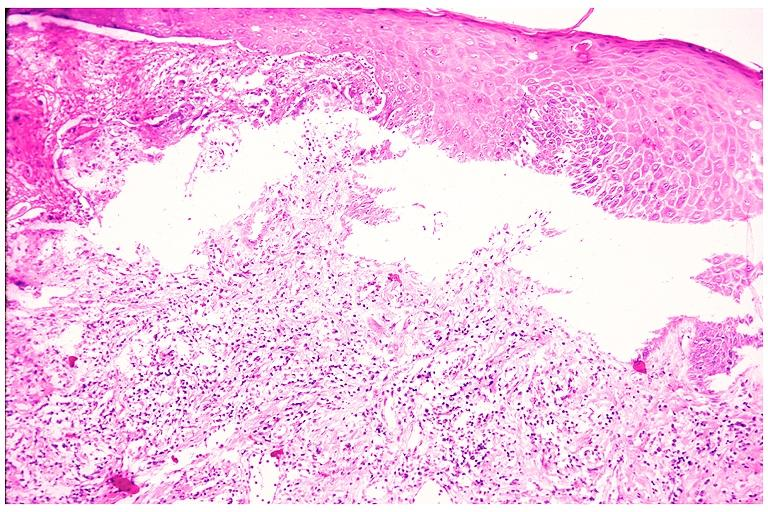does this image show cicatricial pemphigoid?
Answer the question using a single word or phrase. Yes 